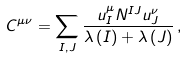Convert formula to latex. <formula><loc_0><loc_0><loc_500><loc_500>C ^ { \mu \nu } = \sum _ { I , J } \frac { u _ { I } ^ { \mu } N ^ { I J } u _ { J } ^ { \nu } } { \lambda \left ( I \right ) + \lambda \left ( J \right ) } \, ,</formula> 